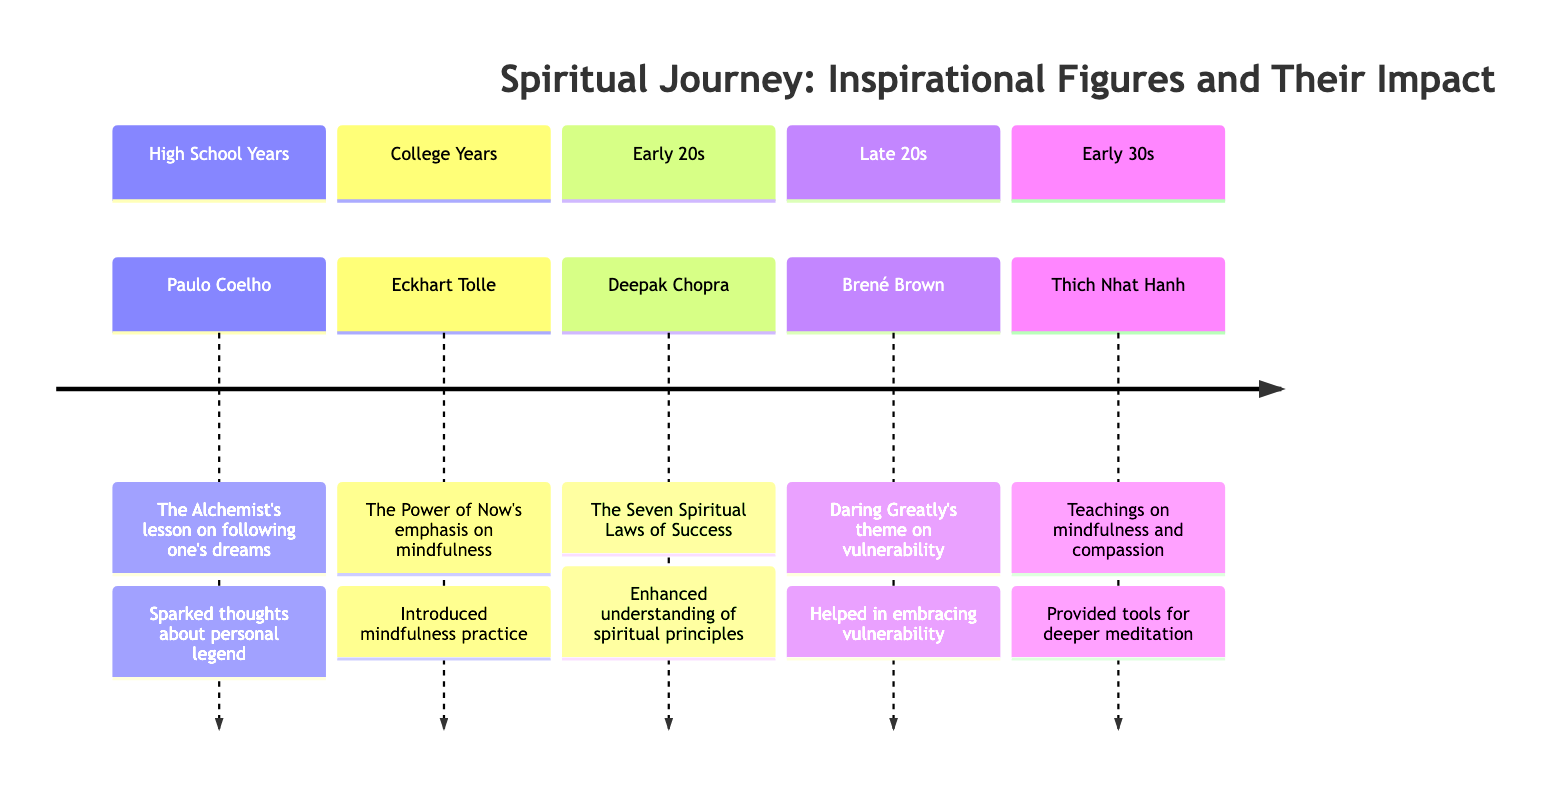What is the inspirational figure associated with the High School Years? In the timeline, the High School Years section lists Paulo Coelho as the inspirational figure. This can be found directly in the description of that specific period.
Answer: Paulo Coelho Which teaching is linked to Deepak Chopra? The Early 20s section indicates that Deepak Chopra's teaching is "The Seven Spiritual Laws of Success focusing on intent and the Law of Karma." This is stated in the text corresponding to that period.
Answer: The Seven Spiritual Laws of Success What impact did Eckhart Tolle have during the College Years? The College Years section details that Eckhart Tolle's impact was to introduce mindfulness practice and the importance of staying present, reducing anxiety about the future. This is explicitly outlined in that segment.
Answer: Introduced mindfulness practice How many inspirational figures are mentioned in the timeline? By counting the number of unique inspirational figures listed in the timeline, we identify five: Paulo Coelho, Eckhart Tolle, Deepak Chopra, Brené Brown, and Thich Nhat Hanh.
Answer: 5 Which period is associated with the theme of vulnerability? The Late 20s section outlines the theme of vulnerability, specifically attributed to Brené Brown's work "Daring Greatly." Therefore, Late 20s is the relevant period.
Answer: Late 20s What did Thich Nhat Hanh provide in the Early 30s? The Early 30s section states that Thich Nhat Hanh provided tools for deeper meditation practice and a compassionate approach, as mentioned in the corresponding teachings and impact.
Answer: Tools for deeper meditation During which period is the concept of personal legend introduced? According to the High School Years segment, the concept of personal legend is sparked by Paulo Coelho's teachings, making it the relevant period for this concept.
Answer: High School Years Which teaching emphasizes living in the present moment? The timeline specifies that Eckhart Tolle's teaching emphasizes mindfulness and living in the present moment, particularly during the College Years, which directly answers the question.
Answer: Mindfulness and living in the present moment What theme is prevalent in Brené Brown's teachings? The Late 20s section explicitly mentions that the theme prevalent in Brené Brown's teachings is vulnerability and courage, indicating her influence during that period.
Answer: Vulnerability and courage 